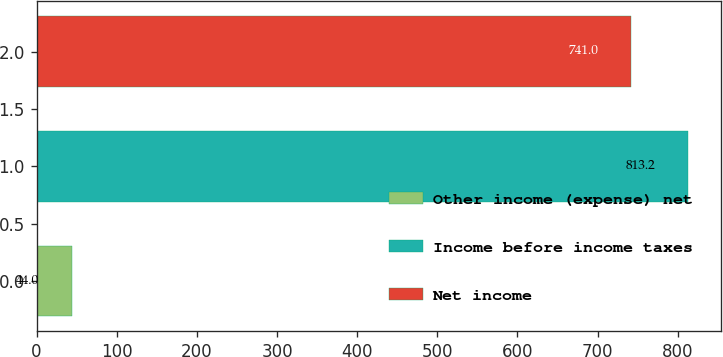Convert chart to OTSL. <chart><loc_0><loc_0><loc_500><loc_500><bar_chart><fcel>Other income (expense) net<fcel>Income before income taxes<fcel>Net income<nl><fcel>44<fcel>813.2<fcel>741<nl></chart> 